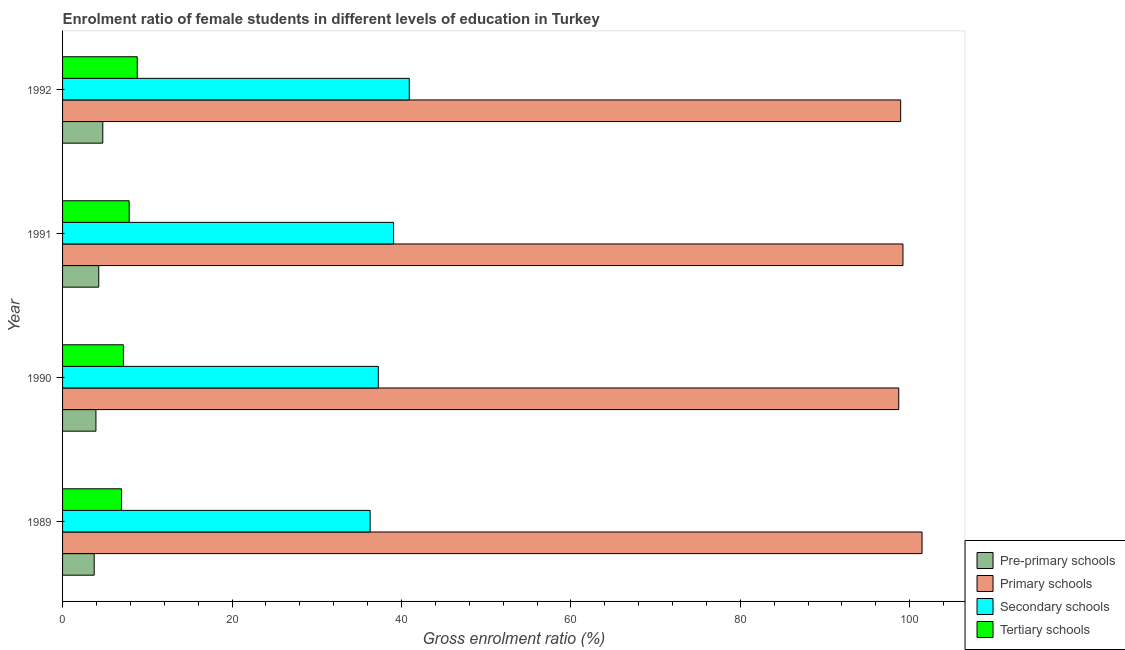How many different coloured bars are there?
Offer a very short reply. 4. Are the number of bars per tick equal to the number of legend labels?
Your answer should be compact. Yes. Are the number of bars on each tick of the Y-axis equal?
Your response must be concise. Yes. What is the label of the 1st group of bars from the top?
Your answer should be very brief. 1992. What is the gross enrolment ratio(male) in pre-primary schools in 1991?
Provide a succinct answer. 4.27. Across all years, what is the maximum gross enrolment ratio(male) in pre-primary schools?
Provide a short and direct response. 4.75. Across all years, what is the minimum gross enrolment ratio(male) in tertiary schools?
Give a very brief answer. 6.96. In which year was the gross enrolment ratio(male) in pre-primary schools maximum?
Offer a terse response. 1992. What is the total gross enrolment ratio(male) in primary schools in the graph?
Your answer should be very brief. 398.27. What is the difference between the gross enrolment ratio(male) in tertiary schools in 1990 and that in 1991?
Provide a succinct answer. -0.68. What is the difference between the gross enrolment ratio(male) in primary schools in 1989 and the gross enrolment ratio(male) in pre-primary schools in 1992?
Your answer should be compact. 96.7. What is the average gross enrolment ratio(male) in pre-primary schools per year?
Your answer should be compact. 4.17. In the year 1992, what is the difference between the gross enrolment ratio(male) in primary schools and gross enrolment ratio(male) in tertiary schools?
Your response must be concise. 90.11. In how many years, is the gross enrolment ratio(male) in secondary schools greater than 28 %?
Your answer should be very brief. 4. What is the ratio of the gross enrolment ratio(male) in tertiary schools in 1989 to that in 1990?
Ensure brevity in your answer.  0.97. Is the gross enrolment ratio(male) in tertiary schools in 1990 less than that in 1991?
Give a very brief answer. Yes. What is the difference between the highest and the second highest gross enrolment ratio(male) in primary schools?
Provide a short and direct response. 2.25. What is the difference between the highest and the lowest gross enrolment ratio(male) in tertiary schools?
Your answer should be very brief. 1.86. In how many years, is the gross enrolment ratio(male) in pre-primary schools greater than the average gross enrolment ratio(male) in pre-primary schools taken over all years?
Your response must be concise. 2. Is the sum of the gross enrolment ratio(male) in secondary schools in 1991 and 1992 greater than the maximum gross enrolment ratio(male) in primary schools across all years?
Keep it short and to the point. No. What does the 1st bar from the top in 1991 represents?
Make the answer very short. Tertiary schools. What does the 4th bar from the bottom in 1989 represents?
Give a very brief answer. Tertiary schools. Is it the case that in every year, the sum of the gross enrolment ratio(male) in pre-primary schools and gross enrolment ratio(male) in primary schools is greater than the gross enrolment ratio(male) in secondary schools?
Give a very brief answer. Yes. How many bars are there?
Your answer should be compact. 16. Does the graph contain any zero values?
Provide a short and direct response. No. Does the graph contain grids?
Give a very brief answer. No. How many legend labels are there?
Make the answer very short. 4. What is the title of the graph?
Offer a terse response. Enrolment ratio of female students in different levels of education in Turkey. What is the label or title of the X-axis?
Your answer should be compact. Gross enrolment ratio (%). What is the label or title of the Y-axis?
Offer a very short reply. Year. What is the Gross enrolment ratio (%) of Pre-primary schools in 1989?
Keep it short and to the point. 3.73. What is the Gross enrolment ratio (%) in Primary schools in 1989?
Your answer should be very brief. 101.45. What is the Gross enrolment ratio (%) in Secondary schools in 1989?
Your answer should be compact. 36.31. What is the Gross enrolment ratio (%) of Tertiary schools in 1989?
Your response must be concise. 6.96. What is the Gross enrolment ratio (%) of Pre-primary schools in 1990?
Provide a succinct answer. 3.94. What is the Gross enrolment ratio (%) of Primary schools in 1990?
Ensure brevity in your answer.  98.7. What is the Gross enrolment ratio (%) of Secondary schools in 1990?
Give a very brief answer. 37.27. What is the Gross enrolment ratio (%) of Tertiary schools in 1990?
Provide a short and direct response. 7.18. What is the Gross enrolment ratio (%) in Pre-primary schools in 1991?
Give a very brief answer. 4.27. What is the Gross enrolment ratio (%) in Primary schools in 1991?
Your answer should be compact. 99.2. What is the Gross enrolment ratio (%) of Secondary schools in 1991?
Offer a terse response. 39.07. What is the Gross enrolment ratio (%) of Tertiary schools in 1991?
Your response must be concise. 7.86. What is the Gross enrolment ratio (%) of Pre-primary schools in 1992?
Make the answer very short. 4.75. What is the Gross enrolment ratio (%) in Primary schools in 1992?
Your response must be concise. 98.93. What is the Gross enrolment ratio (%) of Secondary schools in 1992?
Keep it short and to the point. 40.93. What is the Gross enrolment ratio (%) in Tertiary schools in 1992?
Your response must be concise. 8.82. Across all years, what is the maximum Gross enrolment ratio (%) of Pre-primary schools?
Your answer should be compact. 4.75. Across all years, what is the maximum Gross enrolment ratio (%) in Primary schools?
Make the answer very short. 101.45. Across all years, what is the maximum Gross enrolment ratio (%) of Secondary schools?
Offer a very short reply. 40.93. Across all years, what is the maximum Gross enrolment ratio (%) of Tertiary schools?
Your response must be concise. 8.82. Across all years, what is the minimum Gross enrolment ratio (%) in Pre-primary schools?
Provide a short and direct response. 3.73. Across all years, what is the minimum Gross enrolment ratio (%) of Primary schools?
Keep it short and to the point. 98.7. Across all years, what is the minimum Gross enrolment ratio (%) in Secondary schools?
Provide a short and direct response. 36.31. Across all years, what is the minimum Gross enrolment ratio (%) in Tertiary schools?
Your answer should be compact. 6.96. What is the total Gross enrolment ratio (%) of Pre-primary schools in the graph?
Ensure brevity in your answer.  16.69. What is the total Gross enrolment ratio (%) in Primary schools in the graph?
Offer a very short reply. 398.27. What is the total Gross enrolment ratio (%) in Secondary schools in the graph?
Your response must be concise. 153.58. What is the total Gross enrolment ratio (%) in Tertiary schools in the graph?
Your response must be concise. 30.82. What is the difference between the Gross enrolment ratio (%) in Pre-primary schools in 1989 and that in 1990?
Give a very brief answer. -0.21. What is the difference between the Gross enrolment ratio (%) of Primary schools in 1989 and that in 1990?
Your response must be concise. 2.75. What is the difference between the Gross enrolment ratio (%) in Secondary schools in 1989 and that in 1990?
Offer a terse response. -0.96. What is the difference between the Gross enrolment ratio (%) in Tertiary schools in 1989 and that in 1990?
Offer a terse response. -0.22. What is the difference between the Gross enrolment ratio (%) of Pre-primary schools in 1989 and that in 1991?
Your answer should be very brief. -0.54. What is the difference between the Gross enrolment ratio (%) of Primary schools in 1989 and that in 1991?
Keep it short and to the point. 2.25. What is the difference between the Gross enrolment ratio (%) of Secondary schools in 1989 and that in 1991?
Provide a succinct answer. -2.77. What is the difference between the Gross enrolment ratio (%) in Tertiary schools in 1989 and that in 1991?
Offer a terse response. -0.91. What is the difference between the Gross enrolment ratio (%) in Pre-primary schools in 1989 and that in 1992?
Your response must be concise. -1.02. What is the difference between the Gross enrolment ratio (%) in Primary schools in 1989 and that in 1992?
Your answer should be very brief. 2.52. What is the difference between the Gross enrolment ratio (%) of Secondary schools in 1989 and that in 1992?
Provide a succinct answer. -4.62. What is the difference between the Gross enrolment ratio (%) in Tertiary schools in 1989 and that in 1992?
Provide a short and direct response. -1.86. What is the difference between the Gross enrolment ratio (%) in Pre-primary schools in 1990 and that in 1991?
Provide a succinct answer. -0.33. What is the difference between the Gross enrolment ratio (%) in Primary schools in 1990 and that in 1991?
Keep it short and to the point. -0.5. What is the difference between the Gross enrolment ratio (%) of Secondary schools in 1990 and that in 1991?
Your answer should be very brief. -1.81. What is the difference between the Gross enrolment ratio (%) in Tertiary schools in 1990 and that in 1991?
Ensure brevity in your answer.  -0.68. What is the difference between the Gross enrolment ratio (%) of Pre-primary schools in 1990 and that in 1992?
Make the answer very short. -0.81. What is the difference between the Gross enrolment ratio (%) in Primary schools in 1990 and that in 1992?
Make the answer very short. -0.23. What is the difference between the Gross enrolment ratio (%) of Secondary schools in 1990 and that in 1992?
Provide a succinct answer. -3.66. What is the difference between the Gross enrolment ratio (%) of Tertiary schools in 1990 and that in 1992?
Make the answer very short. -1.64. What is the difference between the Gross enrolment ratio (%) in Pre-primary schools in 1991 and that in 1992?
Keep it short and to the point. -0.48. What is the difference between the Gross enrolment ratio (%) of Primary schools in 1991 and that in 1992?
Provide a short and direct response. 0.27. What is the difference between the Gross enrolment ratio (%) of Secondary schools in 1991 and that in 1992?
Your answer should be compact. -1.85. What is the difference between the Gross enrolment ratio (%) in Tertiary schools in 1991 and that in 1992?
Make the answer very short. -0.95. What is the difference between the Gross enrolment ratio (%) of Pre-primary schools in 1989 and the Gross enrolment ratio (%) of Primary schools in 1990?
Ensure brevity in your answer.  -94.97. What is the difference between the Gross enrolment ratio (%) of Pre-primary schools in 1989 and the Gross enrolment ratio (%) of Secondary schools in 1990?
Your answer should be very brief. -33.54. What is the difference between the Gross enrolment ratio (%) in Pre-primary schools in 1989 and the Gross enrolment ratio (%) in Tertiary schools in 1990?
Your response must be concise. -3.45. What is the difference between the Gross enrolment ratio (%) of Primary schools in 1989 and the Gross enrolment ratio (%) of Secondary schools in 1990?
Provide a short and direct response. 64.18. What is the difference between the Gross enrolment ratio (%) of Primary schools in 1989 and the Gross enrolment ratio (%) of Tertiary schools in 1990?
Offer a very short reply. 94.27. What is the difference between the Gross enrolment ratio (%) in Secondary schools in 1989 and the Gross enrolment ratio (%) in Tertiary schools in 1990?
Ensure brevity in your answer.  29.13. What is the difference between the Gross enrolment ratio (%) in Pre-primary schools in 1989 and the Gross enrolment ratio (%) in Primary schools in 1991?
Provide a succinct answer. -95.47. What is the difference between the Gross enrolment ratio (%) in Pre-primary schools in 1989 and the Gross enrolment ratio (%) in Secondary schools in 1991?
Your answer should be compact. -35.34. What is the difference between the Gross enrolment ratio (%) of Pre-primary schools in 1989 and the Gross enrolment ratio (%) of Tertiary schools in 1991?
Offer a terse response. -4.13. What is the difference between the Gross enrolment ratio (%) of Primary schools in 1989 and the Gross enrolment ratio (%) of Secondary schools in 1991?
Keep it short and to the point. 62.38. What is the difference between the Gross enrolment ratio (%) of Primary schools in 1989 and the Gross enrolment ratio (%) of Tertiary schools in 1991?
Offer a terse response. 93.59. What is the difference between the Gross enrolment ratio (%) of Secondary schools in 1989 and the Gross enrolment ratio (%) of Tertiary schools in 1991?
Your answer should be very brief. 28.44. What is the difference between the Gross enrolment ratio (%) of Pre-primary schools in 1989 and the Gross enrolment ratio (%) of Primary schools in 1992?
Offer a very short reply. -95.19. What is the difference between the Gross enrolment ratio (%) of Pre-primary schools in 1989 and the Gross enrolment ratio (%) of Secondary schools in 1992?
Your response must be concise. -37.19. What is the difference between the Gross enrolment ratio (%) of Pre-primary schools in 1989 and the Gross enrolment ratio (%) of Tertiary schools in 1992?
Your answer should be compact. -5.08. What is the difference between the Gross enrolment ratio (%) in Primary schools in 1989 and the Gross enrolment ratio (%) in Secondary schools in 1992?
Make the answer very short. 60.52. What is the difference between the Gross enrolment ratio (%) in Primary schools in 1989 and the Gross enrolment ratio (%) in Tertiary schools in 1992?
Keep it short and to the point. 92.63. What is the difference between the Gross enrolment ratio (%) of Secondary schools in 1989 and the Gross enrolment ratio (%) of Tertiary schools in 1992?
Provide a succinct answer. 27.49. What is the difference between the Gross enrolment ratio (%) in Pre-primary schools in 1990 and the Gross enrolment ratio (%) in Primary schools in 1991?
Make the answer very short. -95.26. What is the difference between the Gross enrolment ratio (%) in Pre-primary schools in 1990 and the Gross enrolment ratio (%) in Secondary schools in 1991?
Make the answer very short. -35.14. What is the difference between the Gross enrolment ratio (%) in Pre-primary schools in 1990 and the Gross enrolment ratio (%) in Tertiary schools in 1991?
Ensure brevity in your answer.  -3.92. What is the difference between the Gross enrolment ratio (%) of Primary schools in 1990 and the Gross enrolment ratio (%) of Secondary schools in 1991?
Ensure brevity in your answer.  59.63. What is the difference between the Gross enrolment ratio (%) of Primary schools in 1990 and the Gross enrolment ratio (%) of Tertiary schools in 1991?
Offer a terse response. 90.84. What is the difference between the Gross enrolment ratio (%) of Secondary schools in 1990 and the Gross enrolment ratio (%) of Tertiary schools in 1991?
Your answer should be very brief. 29.41. What is the difference between the Gross enrolment ratio (%) in Pre-primary schools in 1990 and the Gross enrolment ratio (%) in Primary schools in 1992?
Provide a succinct answer. -94.99. What is the difference between the Gross enrolment ratio (%) in Pre-primary schools in 1990 and the Gross enrolment ratio (%) in Secondary schools in 1992?
Your answer should be very brief. -36.99. What is the difference between the Gross enrolment ratio (%) in Pre-primary schools in 1990 and the Gross enrolment ratio (%) in Tertiary schools in 1992?
Provide a succinct answer. -4.88. What is the difference between the Gross enrolment ratio (%) in Primary schools in 1990 and the Gross enrolment ratio (%) in Secondary schools in 1992?
Your response must be concise. 57.77. What is the difference between the Gross enrolment ratio (%) in Primary schools in 1990 and the Gross enrolment ratio (%) in Tertiary schools in 1992?
Ensure brevity in your answer.  89.88. What is the difference between the Gross enrolment ratio (%) in Secondary schools in 1990 and the Gross enrolment ratio (%) in Tertiary schools in 1992?
Keep it short and to the point. 28.45. What is the difference between the Gross enrolment ratio (%) of Pre-primary schools in 1991 and the Gross enrolment ratio (%) of Primary schools in 1992?
Your answer should be very brief. -94.66. What is the difference between the Gross enrolment ratio (%) in Pre-primary schools in 1991 and the Gross enrolment ratio (%) in Secondary schools in 1992?
Offer a terse response. -36.66. What is the difference between the Gross enrolment ratio (%) in Pre-primary schools in 1991 and the Gross enrolment ratio (%) in Tertiary schools in 1992?
Keep it short and to the point. -4.55. What is the difference between the Gross enrolment ratio (%) of Primary schools in 1991 and the Gross enrolment ratio (%) of Secondary schools in 1992?
Your answer should be very brief. 58.27. What is the difference between the Gross enrolment ratio (%) in Primary schools in 1991 and the Gross enrolment ratio (%) in Tertiary schools in 1992?
Ensure brevity in your answer.  90.38. What is the difference between the Gross enrolment ratio (%) of Secondary schools in 1991 and the Gross enrolment ratio (%) of Tertiary schools in 1992?
Give a very brief answer. 30.26. What is the average Gross enrolment ratio (%) in Pre-primary schools per year?
Give a very brief answer. 4.17. What is the average Gross enrolment ratio (%) of Primary schools per year?
Provide a succinct answer. 99.57. What is the average Gross enrolment ratio (%) of Secondary schools per year?
Your response must be concise. 38.39. What is the average Gross enrolment ratio (%) of Tertiary schools per year?
Your answer should be compact. 7.7. In the year 1989, what is the difference between the Gross enrolment ratio (%) of Pre-primary schools and Gross enrolment ratio (%) of Primary schools?
Keep it short and to the point. -97.72. In the year 1989, what is the difference between the Gross enrolment ratio (%) in Pre-primary schools and Gross enrolment ratio (%) in Secondary schools?
Your response must be concise. -32.58. In the year 1989, what is the difference between the Gross enrolment ratio (%) of Pre-primary schools and Gross enrolment ratio (%) of Tertiary schools?
Offer a terse response. -3.22. In the year 1989, what is the difference between the Gross enrolment ratio (%) of Primary schools and Gross enrolment ratio (%) of Secondary schools?
Your response must be concise. 65.14. In the year 1989, what is the difference between the Gross enrolment ratio (%) of Primary schools and Gross enrolment ratio (%) of Tertiary schools?
Give a very brief answer. 94.49. In the year 1989, what is the difference between the Gross enrolment ratio (%) in Secondary schools and Gross enrolment ratio (%) in Tertiary schools?
Your answer should be compact. 29.35. In the year 1990, what is the difference between the Gross enrolment ratio (%) in Pre-primary schools and Gross enrolment ratio (%) in Primary schools?
Ensure brevity in your answer.  -94.76. In the year 1990, what is the difference between the Gross enrolment ratio (%) of Pre-primary schools and Gross enrolment ratio (%) of Secondary schools?
Give a very brief answer. -33.33. In the year 1990, what is the difference between the Gross enrolment ratio (%) in Pre-primary schools and Gross enrolment ratio (%) in Tertiary schools?
Keep it short and to the point. -3.24. In the year 1990, what is the difference between the Gross enrolment ratio (%) in Primary schools and Gross enrolment ratio (%) in Secondary schools?
Offer a very short reply. 61.43. In the year 1990, what is the difference between the Gross enrolment ratio (%) of Primary schools and Gross enrolment ratio (%) of Tertiary schools?
Your answer should be compact. 91.52. In the year 1990, what is the difference between the Gross enrolment ratio (%) in Secondary schools and Gross enrolment ratio (%) in Tertiary schools?
Provide a succinct answer. 30.09. In the year 1991, what is the difference between the Gross enrolment ratio (%) in Pre-primary schools and Gross enrolment ratio (%) in Primary schools?
Your answer should be very brief. -94.93. In the year 1991, what is the difference between the Gross enrolment ratio (%) of Pre-primary schools and Gross enrolment ratio (%) of Secondary schools?
Make the answer very short. -34.8. In the year 1991, what is the difference between the Gross enrolment ratio (%) of Pre-primary schools and Gross enrolment ratio (%) of Tertiary schools?
Make the answer very short. -3.59. In the year 1991, what is the difference between the Gross enrolment ratio (%) in Primary schools and Gross enrolment ratio (%) in Secondary schools?
Keep it short and to the point. 60.12. In the year 1991, what is the difference between the Gross enrolment ratio (%) in Primary schools and Gross enrolment ratio (%) in Tertiary schools?
Offer a very short reply. 91.33. In the year 1991, what is the difference between the Gross enrolment ratio (%) of Secondary schools and Gross enrolment ratio (%) of Tertiary schools?
Offer a very short reply. 31.21. In the year 1992, what is the difference between the Gross enrolment ratio (%) in Pre-primary schools and Gross enrolment ratio (%) in Primary schools?
Provide a short and direct response. -94.18. In the year 1992, what is the difference between the Gross enrolment ratio (%) of Pre-primary schools and Gross enrolment ratio (%) of Secondary schools?
Keep it short and to the point. -36.18. In the year 1992, what is the difference between the Gross enrolment ratio (%) in Pre-primary schools and Gross enrolment ratio (%) in Tertiary schools?
Make the answer very short. -4.07. In the year 1992, what is the difference between the Gross enrolment ratio (%) of Primary schools and Gross enrolment ratio (%) of Secondary schools?
Keep it short and to the point. 58. In the year 1992, what is the difference between the Gross enrolment ratio (%) in Primary schools and Gross enrolment ratio (%) in Tertiary schools?
Provide a succinct answer. 90.11. In the year 1992, what is the difference between the Gross enrolment ratio (%) of Secondary schools and Gross enrolment ratio (%) of Tertiary schools?
Your answer should be very brief. 32.11. What is the ratio of the Gross enrolment ratio (%) of Pre-primary schools in 1989 to that in 1990?
Provide a succinct answer. 0.95. What is the ratio of the Gross enrolment ratio (%) in Primary schools in 1989 to that in 1990?
Your answer should be very brief. 1.03. What is the ratio of the Gross enrolment ratio (%) of Secondary schools in 1989 to that in 1990?
Offer a very short reply. 0.97. What is the ratio of the Gross enrolment ratio (%) in Tertiary schools in 1989 to that in 1990?
Provide a succinct answer. 0.97. What is the ratio of the Gross enrolment ratio (%) of Pre-primary schools in 1989 to that in 1991?
Keep it short and to the point. 0.87. What is the ratio of the Gross enrolment ratio (%) of Primary schools in 1989 to that in 1991?
Give a very brief answer. 1.02. What is the ratio of the Gross enrolment ratio (%) of Secondary schools in 1989 to that in 1991?
Give a very brief answer. 0.93. What is the ratio of the Gross enrolment ratio (%) in Tertiary schools in 1989 to that in 1991?
Provide a short and direct response. 0.88. What is the ratio of the Gross enrolment ratio (%) in Pre-primary schools in 1989 to that in 1992?
Offer a very short reply. 0.79. What is the ratio of the Gross enrolment ratio (%) in Primary schools in 1989 to that in 1992?
Offer a terse response. 1.03. What is the ratio of the Gross enrolment ratio (%) in Secondary schools in 1989 to that in 1992?
Provide a short and direct response. 0.89. What is the ratio of the Gross enrolment ratio (%) in Tertiary schools in 1989 to that in 1992?
Offer a very short reply. 0.79. What is the ratio of the Gross enrolment ratio (%) in Pre-primary schools in 1990 to that in 1991?
Provide a short and direct response. 0.92. What is the ratio of the Gross enrolment ratio (%) in Primary schools in 1990 to that in 1991?
Your answer should be very brief. 0.99. What is the ratio of the Gross enrolment ratio (%) of Secondary schools in 1990 to that in 1991?
Your response must be concise. 0.95. What is the ratio of the Gross enrolment ratio (%) of Tertiary schools in 1990 to that in 1991?
Keep it short and to the point. 0.91. What is the ratio of the Gross enrolment ratio (%) of Pre-primary schools in 1990 to that in 1992?
Your answer should be compact. 0.83. What is the ratio of the Gross enrolment ratio (%) of Secondary schools in 1990 to that in 1992?
Give a very brief answer. 0.91. What is the ratio of the Gross enrolment ratio (%) in Tertiary schools in 1990 to that in 1992?
Provide a succinct answer. 0.81. What is the ratio of the Gross enrolment ratio (%) of Pre-primary schools in 1991 to that in 1992?
Provide a short and direct response. 0.9. What is the ratio of the Gross enrolment ratio (%) in Secondary schools in 1991 to that in 1992?
Offer a terse response. 0.95. What is the ratio of the Gross enrolment ratio (%) of Tertiary schools in 1991 to that in 1992?
Keep it short and to the point. 0.89. What is the difference between the highest and the second highest Gross enrolment ratio (%) of Pre-primary schools?
Provide a short and direct response. 0.48. What is the difference between the highest and the second highest Gross enrolment ratio (%) in Primary schools?
Your answer should be compact. 2.25. What is the difference between the highest and the second highest Gross enrolment ratio (%) of Secondary schools?
Provide a short and direct response. 1.85. What is the difference between the highest and the second highest Gross enrolment ratio (%) of Tertiary schools?
Give a very brief answer. 0.95. What is the difference between the highest and the lowest Gross enrolment ratio (%) in Pre-primary schools?
Your response must be concise. 1.02. What is the difference between the highest and the lowest Gross enrolment ratio (%) in Primary schools?
Keep it short and to the point. 2.75. What is the difference between the highest and the lowest Gross enrolment ratio (%) in Secondary schools?
Ensure brevity in your answer.  4.62. What is the difference between the highest and the lowest Gross enrolment ratio (%) of Tertiary schools?
Make the answer very short. 1.86. 